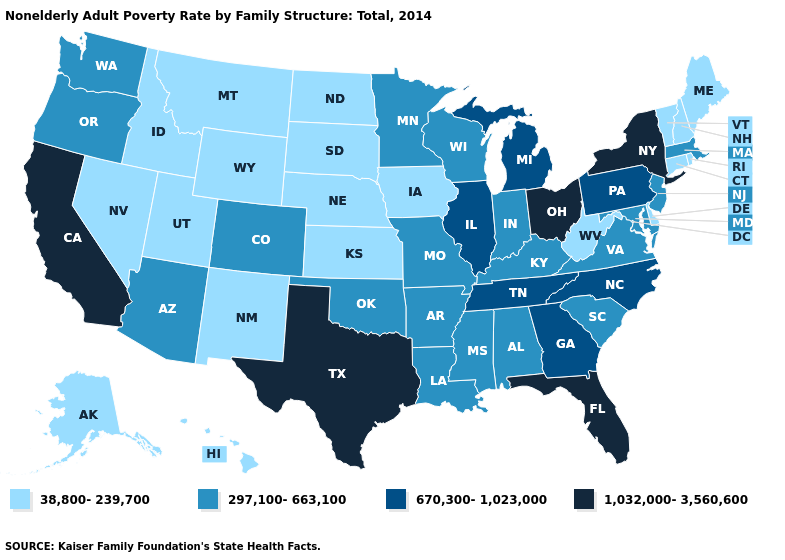What is the value of Colorado?
Write a very short answer. 297,100-663,100. Is the legend a continuous bar?
Quick response, please. No. Does California have a higher value than Ohio?
Quick response, please. No. What is the lowest value in the West?
Concise answer only. 38,800-239,700. Among the states that border West Virginia , does Ohio have the highest value?
Be succinct. Yes. What is the lowest value in states that border New Hampshire?
Concise answer only. 38,800-239,700. Name the states that have a value in the range 38,800-239,700?
Give a very brief answer. Alaska, Connecticut, Delaware, Hawaii, Idaho, Iowa, Kansas, Maine, Montana, Nebraska, Nevada, New Hampshire, New Mexico, North Dakota, Rhode Island, South Dakota, Utah, Vermont, West Virginia, Wyoming. Which states have the lowest value in the USA?
Write a very short answer. Alaska, Connecticut, Delaware, Hawaii, Idaho, Iowa, Kansas, Maine, Montana, Nebraska, Nevada, New Hampshire, New Mexico, North Dakota, Rhode Island, South Dakota, Utah, Vermont, West Virginia, Wyoming. How many symbols are there in the legend?
Concise answer only. 4. Name the states that have a value in the range 297,100-663,100?
Write a very short answer. Alabama, Arizona, Arkansas, Colorado, Indiana, Kentucky, Louisiana, Maryland, Massachusetts, Minnesota, Mississippi, Missouri, New Jersey, Oklahoma, Oregon, South Carolina, Virginia, Washington, Wisconsin. Which states have the lowest value in the Northeast?
Keep it brief. Connecticut, Maine, New Hampshire, Rhode Island, Vermont. What is the highest value in the USA?
Be succinct. 1,032,000-3,560,600. What is the lowest value in states that border New Mexico?
Quick response, please. 38,800-239,700. Is the legend a continuous bar?
Quick response, please. No. Among the states that border Connecticut , does Massachusetts have the lowest value?
Be succinct. No. 